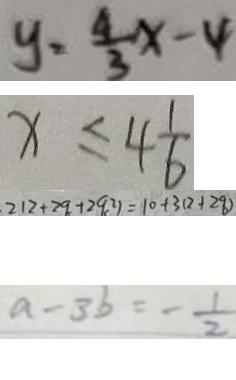<formula> <loc_0><loc_0><loc_500><loc_500>y = \frac { 4 } { 3 } x - 4 
 x \leq 4 \frac { 1 } { 6 } 
 2 1 2 + 2 9 + 2 9 ^ { 2 } ) = 1 0 + 3 ( 2 + 2 8 ) 
 a - 3 b = - \frac { 1 } { 2 }</formula> 